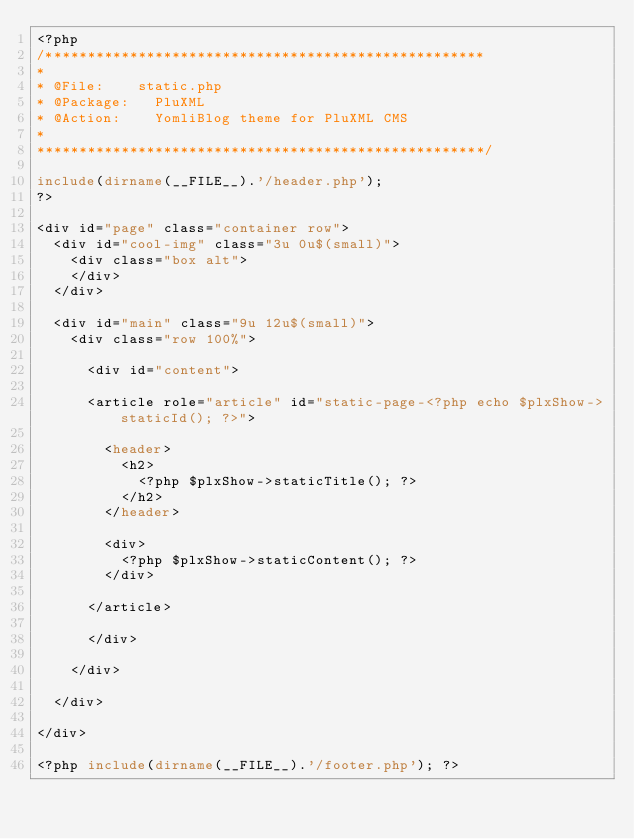<code> <loc_0><loc_0><loc_500><loc_500><_PHP_><?php 
/****************************************************
*
* @File: 		static.php
* @Package:		PluXML
* @Action:		YomliBlog theme for PluXML CMS
*
*****************************************************/

include(dirname(__FILE__).'/header.php'); 
?>

<div id="page" class="container row">
	<div id="cool-img" class="3u 0u$(small)">
		<div class="box alt">
		</div>
	</div>

	<div id="main" class="9u 12u$(small)">
		<div class="row 100%">

			<div id="content">

			<article role="article" id="static-page-<?php echo $plxShow->staticId(); ?>">

				<header>
					<h2>
						<?php $plxShow->staticTitle(); ?>
					</h2>
				</header>

				<div>
					<?php $plxShow->staticContent(); ?>
				</div>

			</article>

			</div>

		</div>

	</div>

</div>

<?php include(dirname(__FILE__).'/footer.php'); ?></code> 